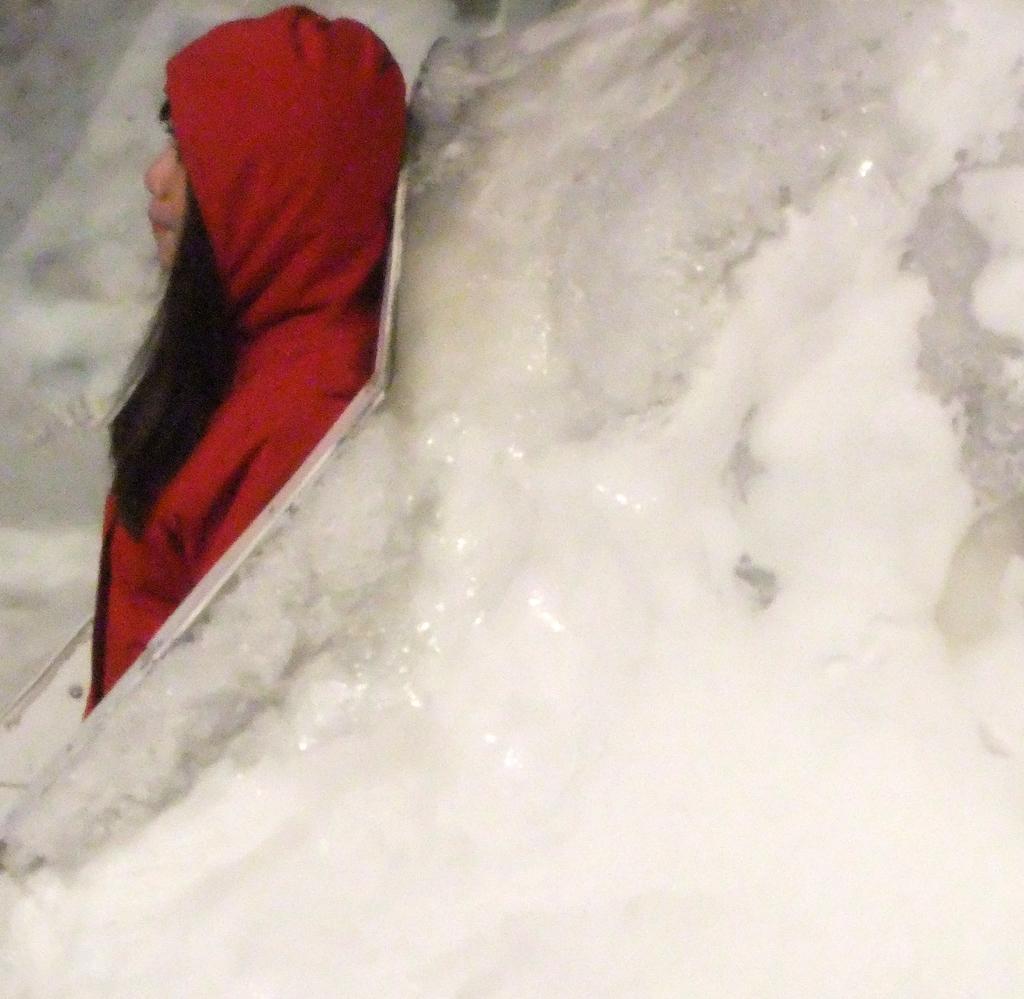Could you give a brief overview of what you see in this image? In this image, we can see a person standing and we can see snow. 